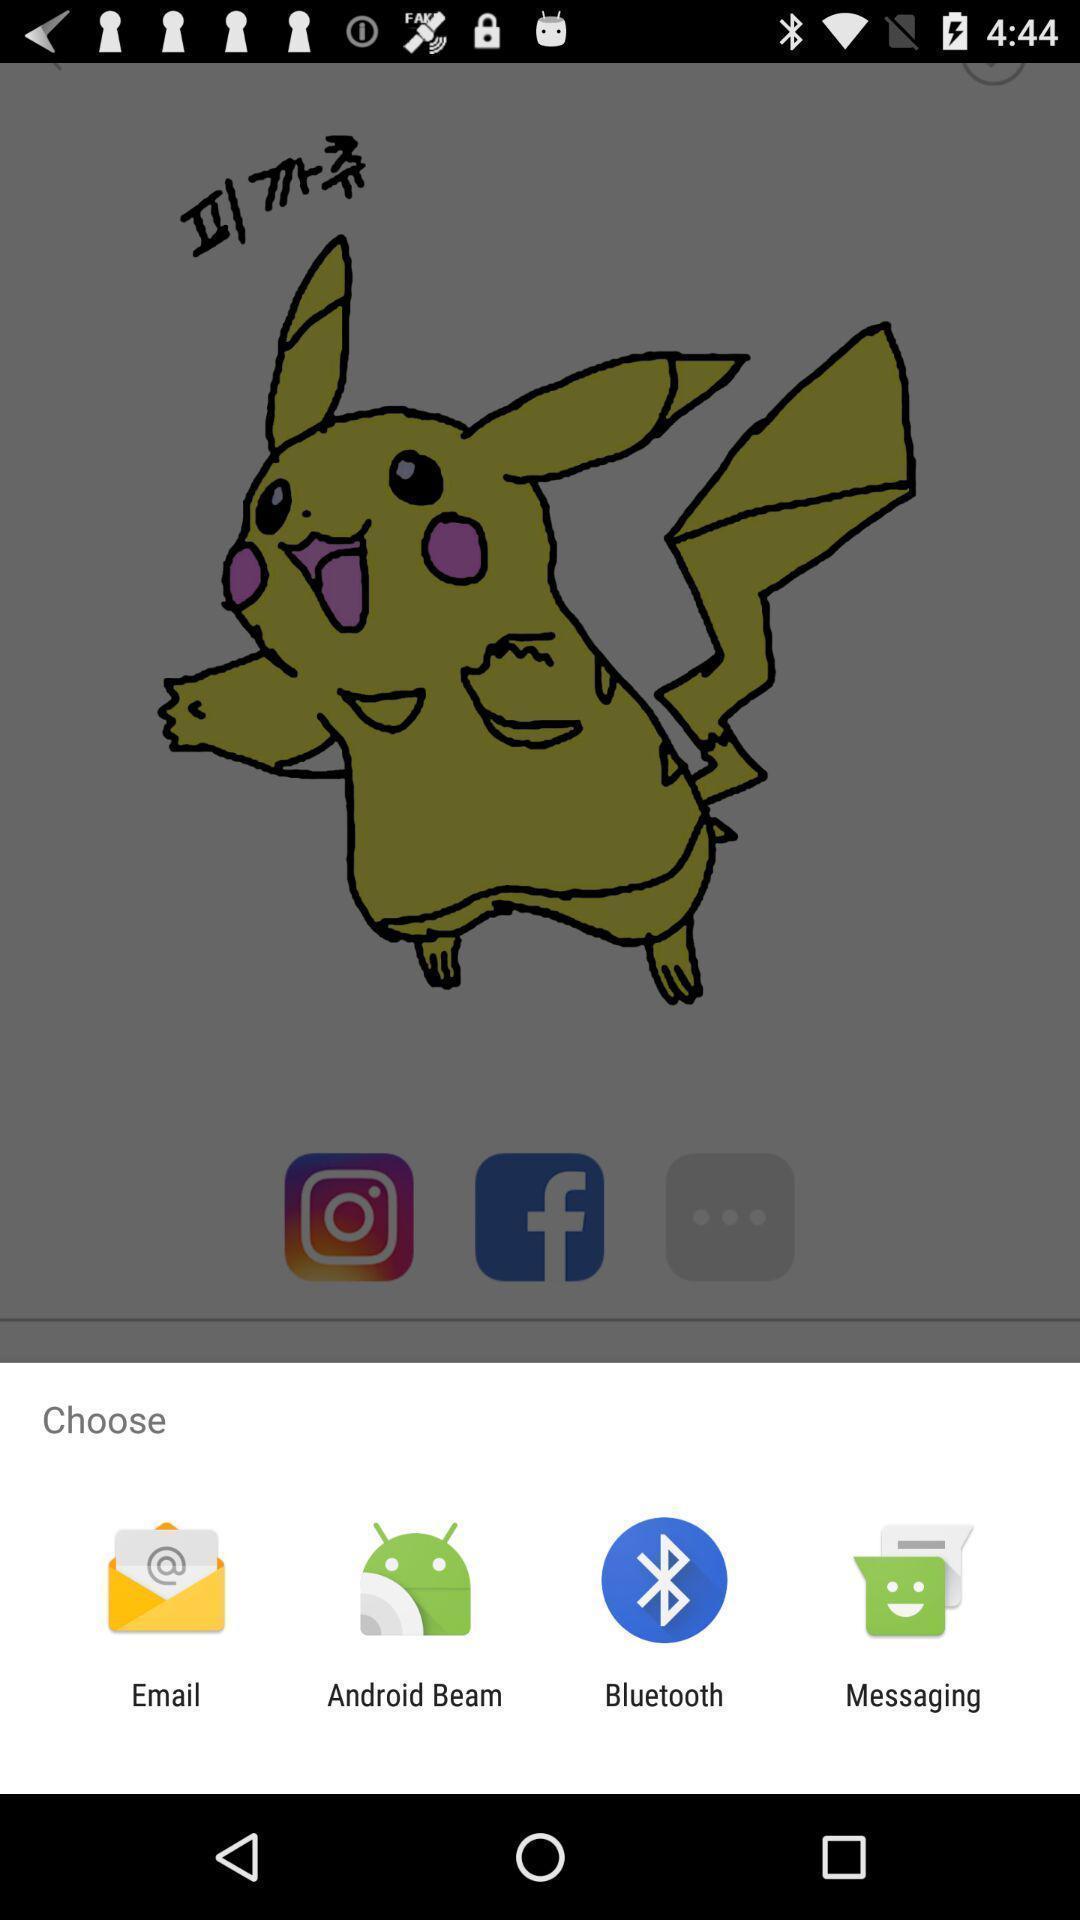Provide a description of this screenshot. Pop-up showing various applications to share. 